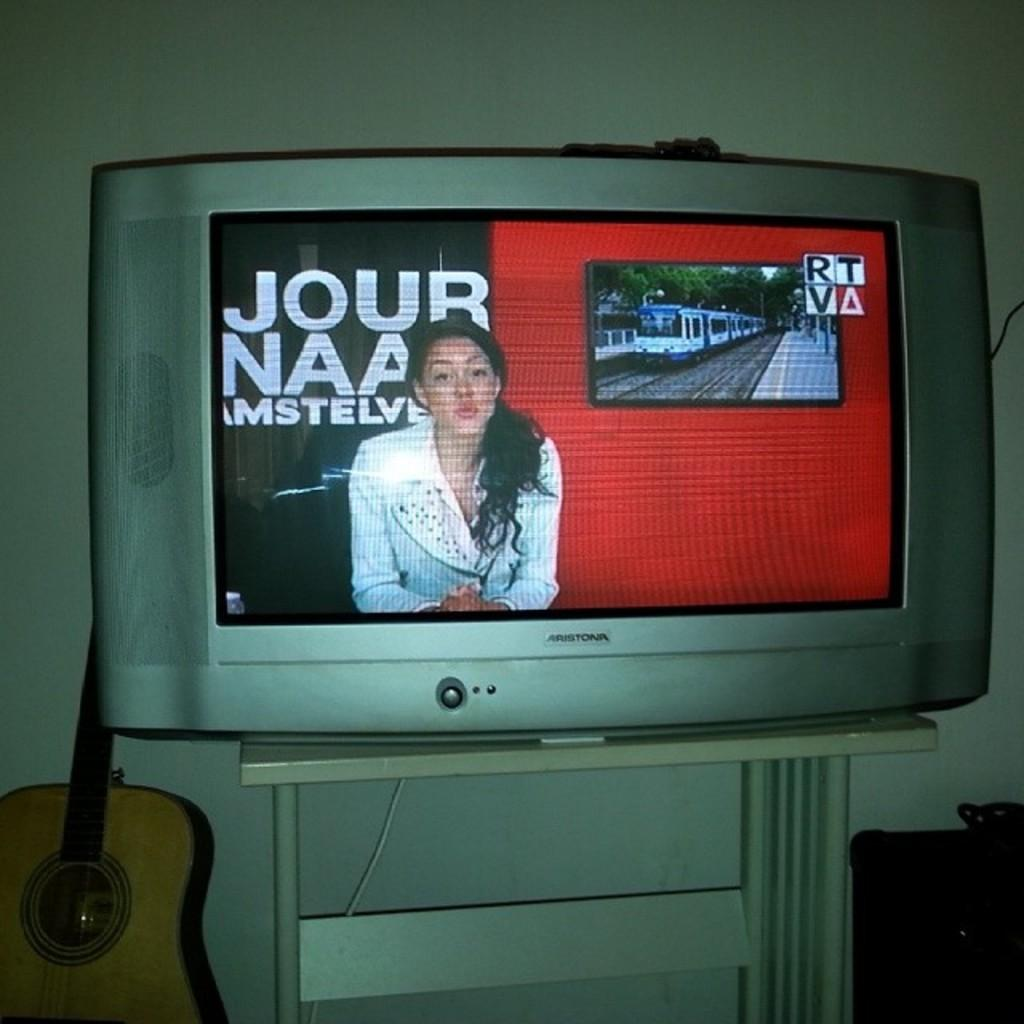<image>
Render a clear and concise summary of the photo. The TV next to a guitar has a female reporter in front of the words, 'Jour Naa Amstelve' on the screen. 